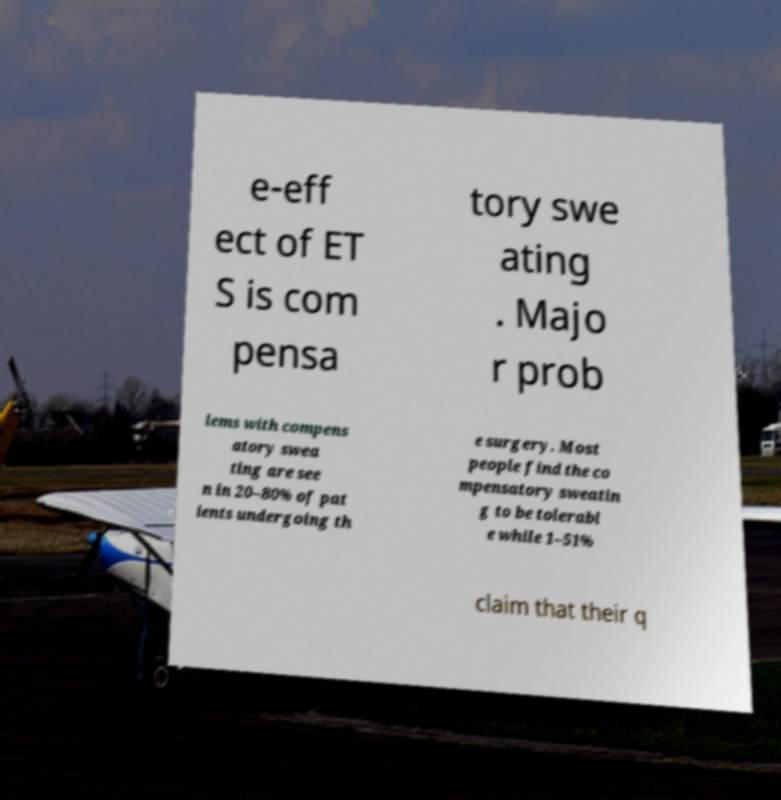For documentation purposes, I need the text within this image transcribed. Could you provide that? e-eff ect of ET S is com pensa tory swe ating . Majo r prob lems with compens atory swea ting are see n in 20–80% of pat ients undergoing th e surgery. Most people find the co mpensatory sweatin g to be tolerabl e while 1–51% claim that their q 